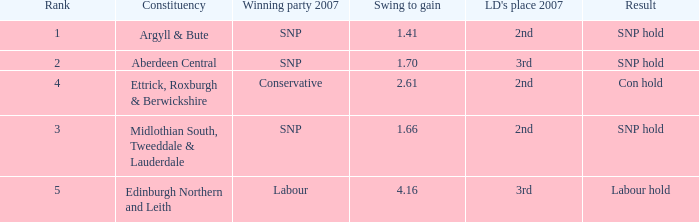Would you mind parsing the complete table? {'header': ['Rank', 'Constituency', 'Winning party 2007', 'Swing to gain', "LD's place 2007", 'Result'], 'rows': [['1', 'Argyll & Bute', 'SNP', '1.41', '2nd', 'SNP hold'], ['2', 'Aberdeen Central', 'SNP', '1.70', '3rd', 'SNP hold'], ['4', 'Ettrick, Roxburgh & Berwickshire', 'Conservative', '2.61', '2nd', 'Con hold'], ['3', 'Midlothian South, Tweeddale & Lauderdale', 'SNP', '1.66', '2nd', 'SNP hold'], ['5', 'Edinburgh Northern and Leith', 'Labour', '4.16', '3rd', 'Labour hold']]} What is the constituency when the rank is less than 5 and the result is con hold? Ettrick, Roxburgh & Berwickshire. 